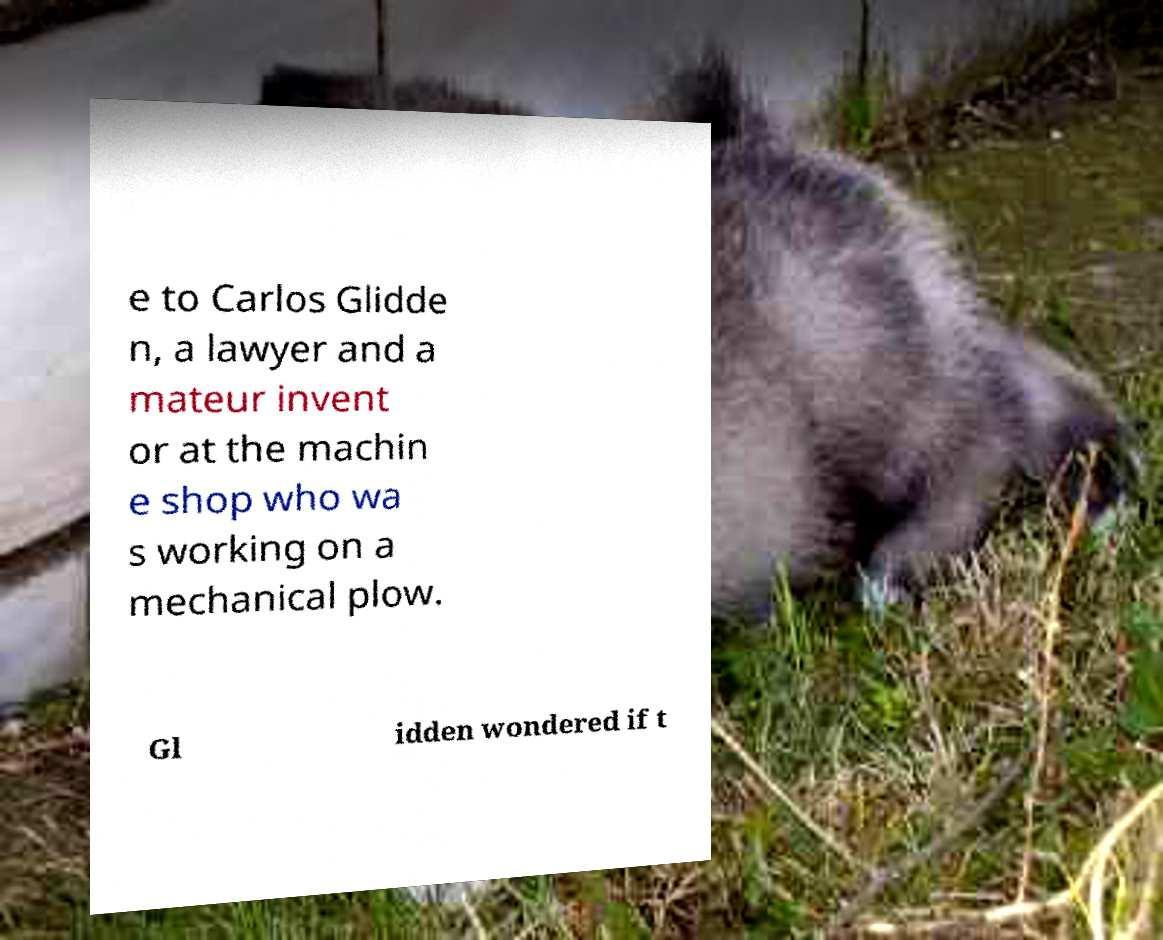For documentation purposes, I need the text within this image transcribed. Could you provide that? e to Carlos Glidde n, a lawyer and a mateur invent or at the machin e shop who wa s working on a mechanical plow. Gl idden wondered if t 